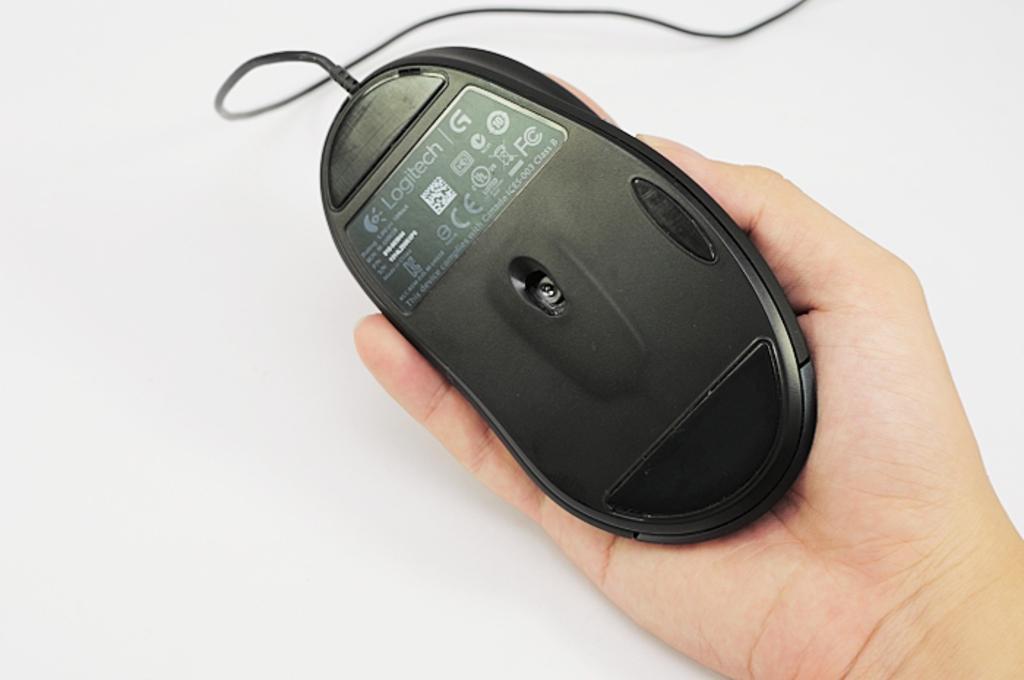Could you give a brief overview of what you see in this image? In this image I can see the person holding the mouse. The mouse is in black color and there is a white background. 